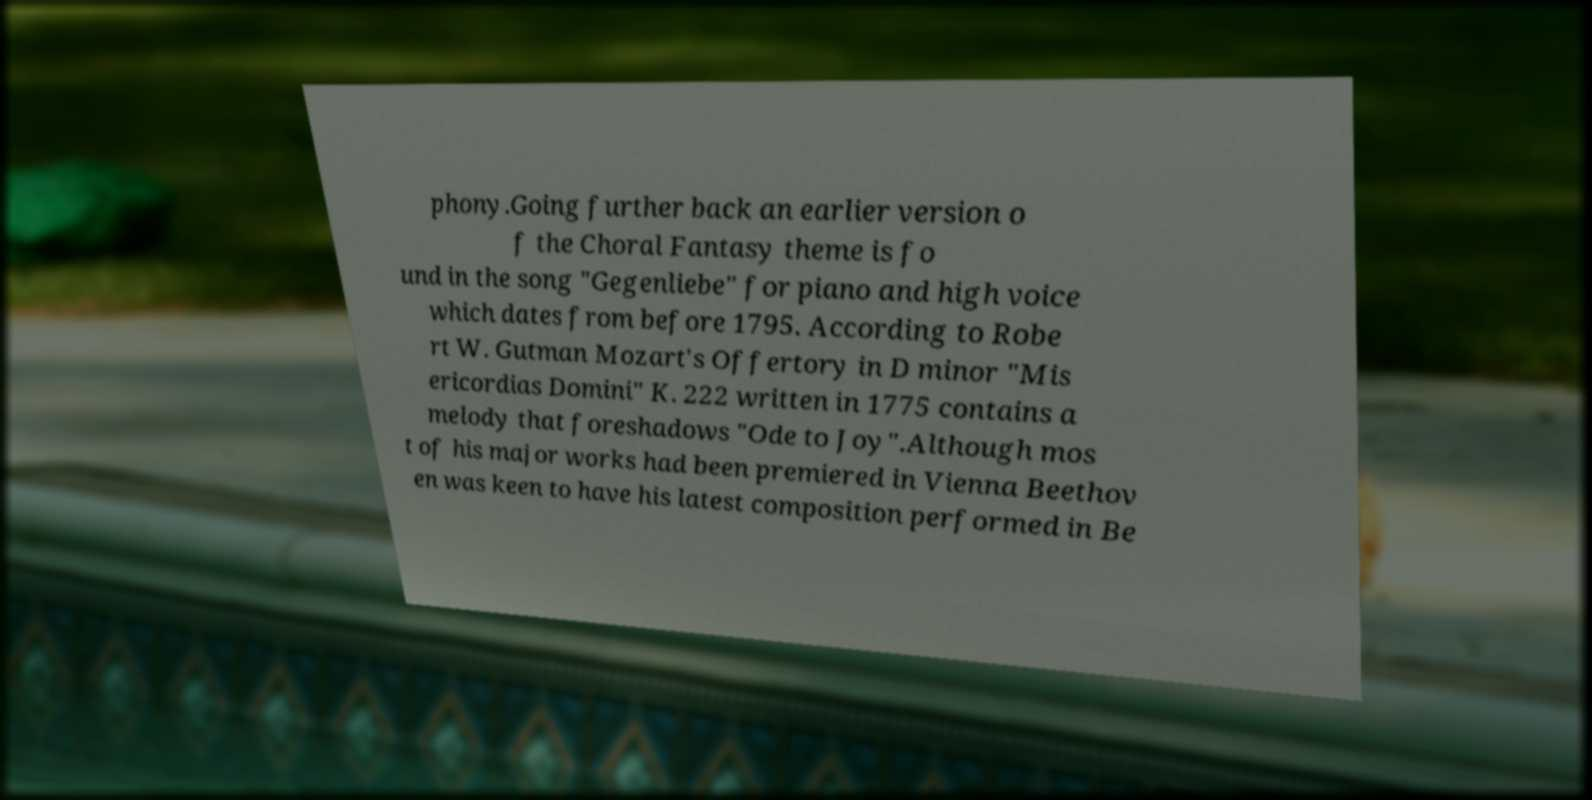Please read and relay the text visible in this image. What does it say? phony.Going further back an earlier version o f the Choral Fantasy theme is fo und in the song "Gegenliebe" for piano and high voice which dates from before 1795. According to Robe rt W. Gutman Mozart's Offertory in D minor "Mis ericordias Domini" K. 222 written in 1775 contains a melody that foreshadows "Ode to Joy".Although mos t of his major works had been premiered in Vienna Beethov en was keen to have his latest composition performed in Be 